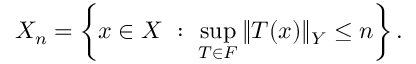<formula> <loc_0><loc_0><loc_500><loc_500>X _ { n } = \left \{ x \in X \ \colon \ \sup _ { T \in F } \| T ( x ) \| _ { Y } \leq n \right \} .</formula> 